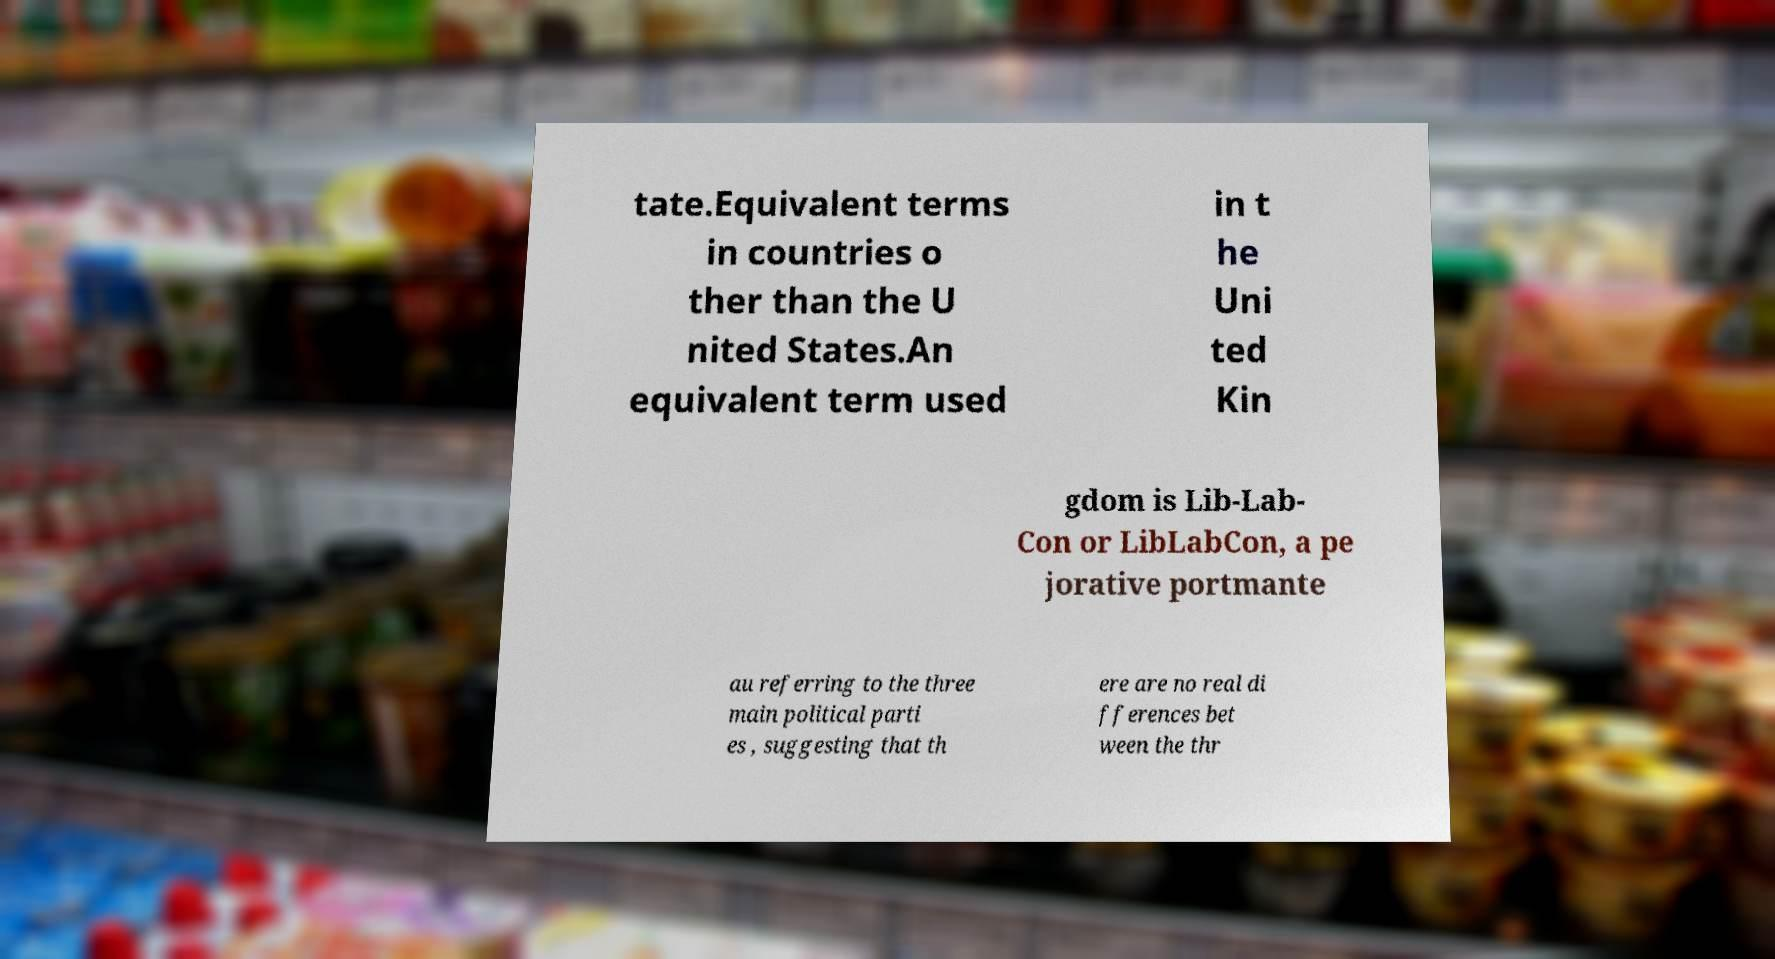Please identify and transcribe the text found in this image. tate.Equivalent terms in countries o ther than the U nited States.An equivalent term used in t he Uni ted Kin gdom is Lib-Lab- Con or LibLabCon, a pe jorative portmante au referring to the three main political parti es , suggesting that th ere are no real di fferences bet ween the thr 